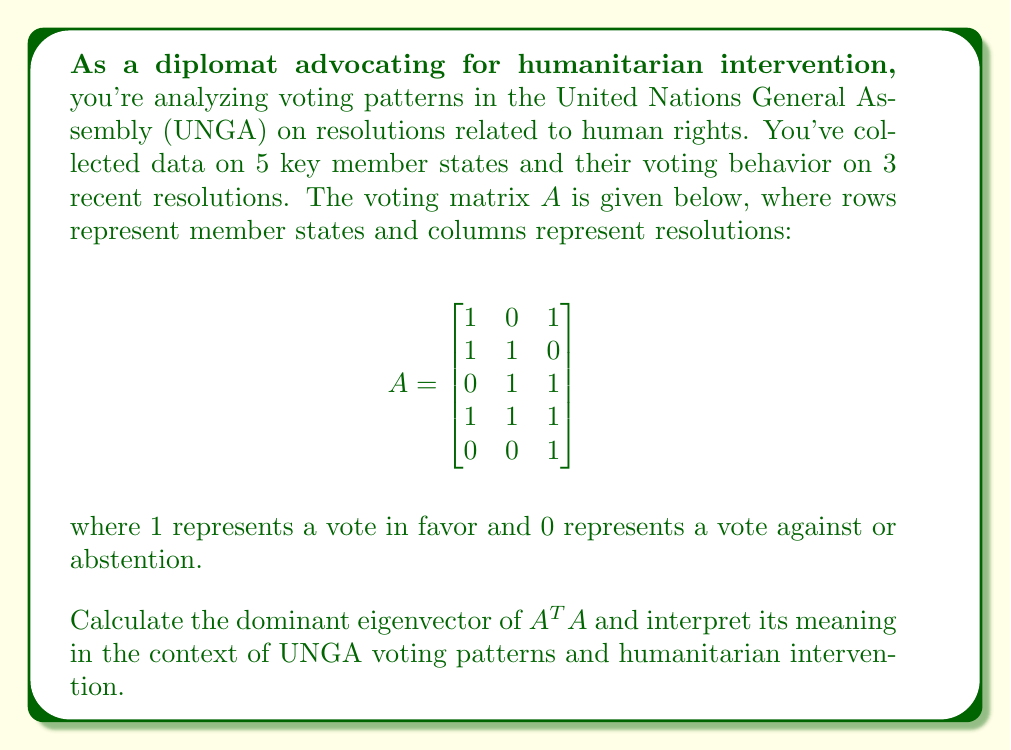Provide a solution to this math problem. To solve this problem, we'll follow these steps:

1) First, calculate $A^TA$:

   $$A^TA = \begin{bmatrix}
   1 & 1 & 0 & 1 & 0 \\
   0 & 1 & 1 & 1 & 0 \\
   1 & 0 & 1 & 1 & 1
   \end{bmatrix} \begin{bmatrix}
   1 & 0 & 1 \\
   1 & 1 & 0 \\
   0 & 1 & 1 \\
   1 & 1 & 1 \\
   0 & 0 & 1
   \end{bmatrix} = \begin{bmatrix}
   3 & 2 & 2 \\
   2 & 3 & 2 \\
   2 & 2 & 4
   \end{bmatrix}$$

2) Now, we need to find the eigenvalues of $A^TA$. The characteristic equation is:

   $$\det(A^TA - \lambda I) = \begin{vmatrix}
   3-\lambda & 2 & 2 \\
   2 & 3-\lambda & 2 \\
   2 & 2 & 4-\lambda
   \end{vmatrix} = 0$$

3) Expanding this determinant:

   $$(3-\lambda)((3-\lambda)(4-\lambda)-4) - 2(2(4-\lambda)-4) + 2(4-8) = 0$$
   
   $$(3-\lambda)(12-7\lambda+\lambda^2) - 4(4-\lambda) - 8 = 0$$
   
   $$36-21\lambda+3\lambda^2-12\lambda+7\lambda^2-\lambda^3 - 16+4\lambda - 8 = 0$$
   
   $$-\lambda^3+10\lambda^2-29\lambda+12 = 0$$

4) The largest root of this equation is the dominant eigenvalue. We can approximate it numerically: $\lambda_{max} \approx 7.5358$

5) Now, we find the eigenvector $v$ corresponding to this eigenvalue by solving $(A^TA - \lambda_{max}I)v = 0$:

   $$\begin{bmatrix}
   -4.5358 & 2 & 2 \\
   2 & -4.5358 & 2 \\
   2 & 2 & -3.5358
   \end{bmatrix} \begin{bmatrix}
   v_1 \\ v_2 \\ v_3
   \end{bmatrix} = \begin{bmatrix}
   0 \\ 0 \\ 0
   \end{bmatrix}$$

6) Solving this system (and normalizing), we get the dominant eigenvector:

   $$v \approx \begin{bmatrix}
   0.5774 \\ 0.5774 \\ 0.5774
   \end{bmatrix}$$

Interpretation: The dominant eigenvector represents the relative importance of each resolution in determining overall voting patterns. In this case, all components are equal, indicating that all three resolutions are equally important in characterizing the voting behavior of the member states on human rights issues. This suggests a balanced approach to humanitarian concerns in the UNGA, where no single resolution dominates the voting patterns.
Answer: The dominant eigenvector is approximately $[0.5774, 0.5774, 0.5774]^T$, indicating equal importance of all three resolutions in determining overall voting patterns on human rights issues in the UNGA. 